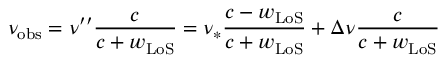<formula> <loc_0><loc_0><loc_500><loc_500>\nu _ { o b s } = \nu ^ { \prime \prime } \frac { c } { c + w _ { L o S } } = \nu _ { \ast } \frac { c - w _ { L o S } } { c + w _ { L o S } } + \Delta \nu \frac { c } { c + w _ { L o S } }</formula> 